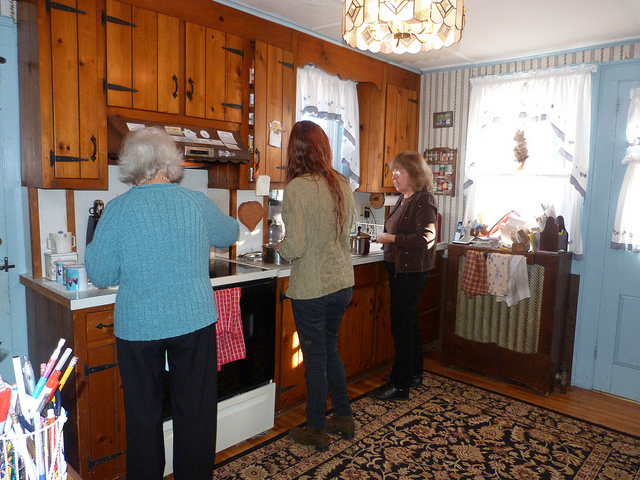Can you describe the kitchen's style and any notable features? The kitchen has a rustic charm with wooden cabinetry and trim that gives it a warm, homely feel. Notable features include the classic white appliances, a hanging chandelier, and a quaint window draped with lace curtains allowing natural light to filter in. 